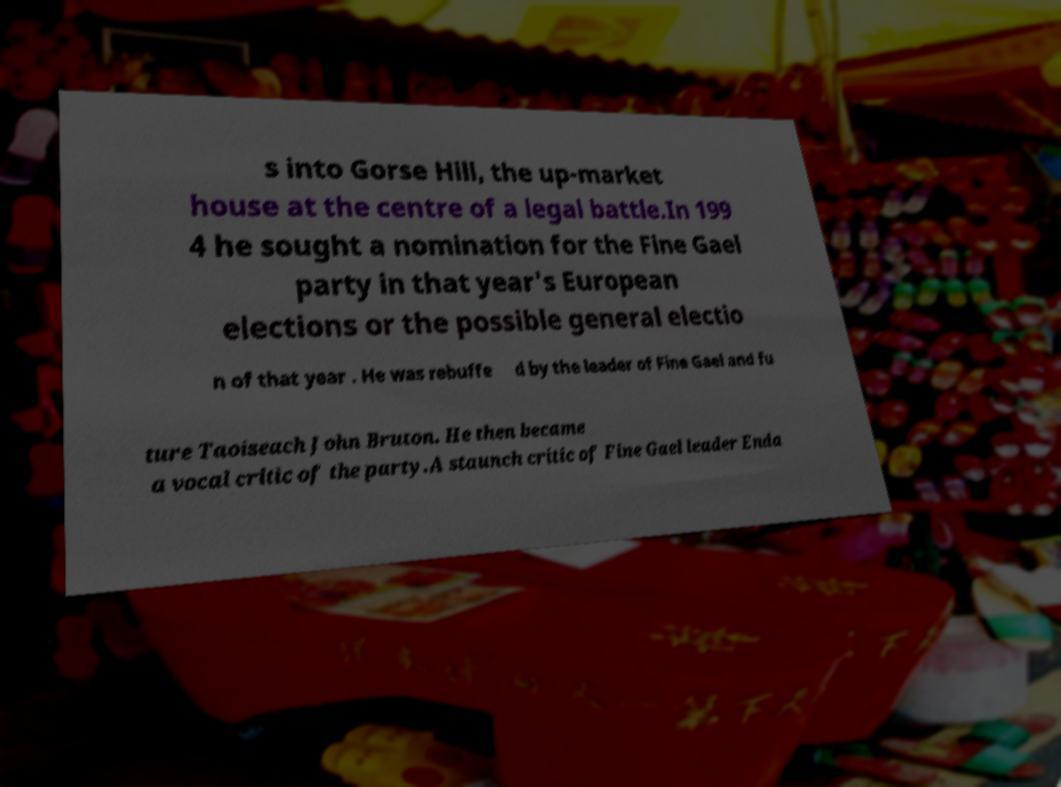Could you assist in decoding the text presented in this image and type it out clearly? s into Gorse Hill, the up-market house at the centre of a legal battle.In 199 4 he sought a nomination for the Fine Gael party in that year's European elections or the possible general electio n of that year . He was rebuffe d by the leader of Fine Gael and fu ture Taoiseach John Bruton. He then became a vocal critic of the party.A staunch critic of Fine Gael leader Enda 